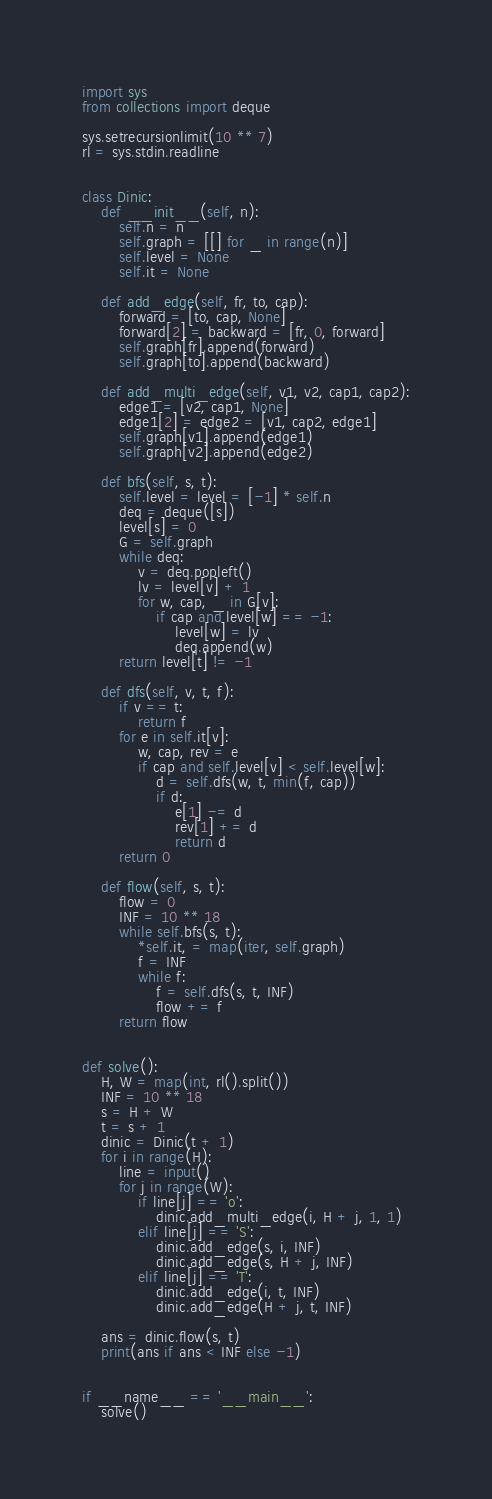Convert code to text. <code><loc_0><loc_0><loc_500><loc_500><_Python_>import sys
from collections import deque

sys.setrecursionlimit(10 ** 7)
rl = sys.stdin.readline


class Dinic:
    def __init__(self, n):
        self.n = n
        self.graph = [[] for _ in range(n)]
        self.level = None
        self.it = None
    
    def add_edge(self, fr, to, cap):
        forward = [to, cap, None]
        forward[2] = backward = [fr, 0, forward]
        self.graph[fr].append(forward)
        self.graph[to].append(backward)
    
    def add_multi_edge(self, v1, v2, cap1, cap2):
        edge1 = [v2, cap1, None]
        edge1[2] = edge2 = [v1, cap2, edge1]
        self.graph[v1].append(edge1)
        self.graph[v2].append(edge2)
    
    def bfs(self, s, t):
        self.level = level = [-1] * self.n
        deq = deque([s])
        level[s] = 0
        G = self.graph
        while deq:
            v = deq.popleft()
            lv = level[v] + 1
            for w, cap, _ in G[v]:
                if cap and level[w] == -1:
                    level[w] = lv
                    deq.append(w)
        return level[t] != -1
    
    def dfs(self, v, t, f):
        if v == t:
            return f
        for e in self.it[v]:
            w, cap, rev = e
            if cap and self.level[v] < self.level[w]:
                d = self.dfs(w, t, min(f, cap))
                if d:
                    e[1] -= d
                    rev[1] += d
                    return d
        return 0
    
    def flow(self, s, t):
        flow = 0
        INF = 10 ** 18
        while self.bfs(s, t):
            *self.it, = map(iter, self.graph)
            f = INF
            while f:
                f = self.dfs(s, t, INF)
                flow += f
        return flow


def solve():
    H, W = map(int, rl().split())
    INF = 10 ** 18
    s = H + W
    t = s + 1
    dinic = Dinic(t + 1)
    for i in range(H):
        line = input()
        for j in range(W):
            if line[j] == 'o':
                dinic.add_multi_edge(i, H + j, 1, 1)
            elif line[j] == 'S':
                dinic.add_edge(s, i, INF)
                dinic.add_edge(s, H + j, INF)
            elif line[j] == 'T':
                dinic.add_edge(i, t, INF)
                dinic.add_edge(H + j, t, INF)
    
    ans = dinic.flow(s, t)
    print(ans if ans < INF else -1)


if __name__ == '__main__':
    solve()
</code> 